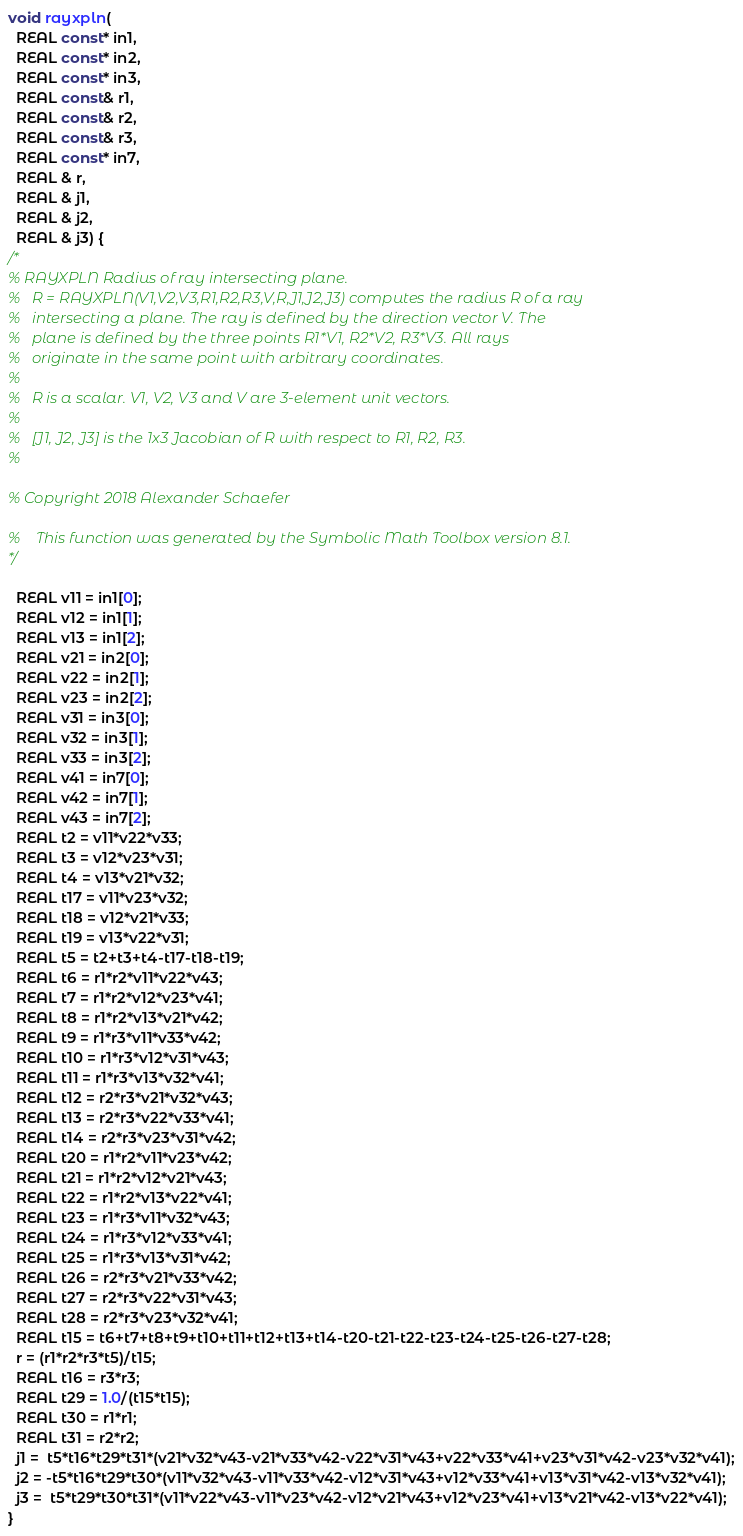<code> <loc_0><loc_0><loc_500><loc_500><_C_>void rayxpln(
  REAL const* in1,
  REAL const* in2,
  REAL const* in3,
  REAL const& r1,
  REAL const& r2,
  REAL const& r3,
  REAL const* in7,
  REAL & r,
  REAL & j1,
  REAL & j2,
  REAL & j3) {
/*
% RAYXPLN Radius of ray intersecting plane.
%   R = RAYXPLN(V1,V2,V3,R1,R2,R3,V,R,J1,J2,J3) computes the radius R of a ray
%   intersecting a plane. The ray is defined by the direction vector V. The
%   plane is defined by the three points R1*V1, R2*V2, R3*V3. All rays
%   originate in the same point with arbitrary coordinates.
%
%   R is a scalar. V1, V2, V3 and V are 3-element unit vectors.
%
%   [J1, J2, J3] is the 1x3 Jacobian of R with respect to R1, R2, R3.
%
  
% Copyright 2018 Alexander Schaefer

%    This function was generated by the Symbolic Math Toolbox version 8.1.
*/

  REAL v11 = in1[0];
  REAL v12 = in1[1];
  REAL v13 = in1[2];
  REAL v21 = in2[0];
  REAL v22 = in2[1];
  REAL v23 = in2[2];
  REAL v31 = in3[0];
  REAL v32 = in3[1];
  REAL v33 = in3[2];
  REAL v41 = in7[0];
  REAL v42 = in7[1];
  REAL v43 = in7[2];
  REAL t2 = v11*v22*v33;
  REAL t3 = v12*v23*v31;
  REAL t4 = v13*v21*v32;
  REAL t17 = v11*v23*v32;
  REAL t18 = v12*v21*v33;
  REAL t19 = v13*v22*v31;
  REAL t5 = t2+t3+t4-t17-t18-t19;
  REAL t6 = r1*r2*v11*v22*v43;
  REAL t7 = r1*r2*v12*v23*v41;
  REAL t8 = r1*r2*v13*v21*v42;
  REAL t9 = r1*r3*v11*v33*v42;
  REAL t10 = r1*r3*v12*v31*v43;
  REAL t11 = r1*r3*v13*v32*v41;
  REAL t12 = r2*r3*v21*v32*v43;
  REAL t13 = r2*r3*v22*v33*v41;
  REAL t14 = r2*r3*v23*v31*v42;
  REAL t20 = r1*r2*v11*v23*v42;
  REAL t21 = r1*r2*v12*v21*v43;
  REAL t22 = r1*r2*v13*v22*v41;
  REAL t23 = r1*r3*v11*v32*v43;
  REAL t24 = r1*r3*v12*v33*v41;
  REAL t25 = r1*r3*v13*v31*v42;
  REAL t26 = r2*r3*v21*v33*v42;
  REAL t27 = r2*r3*v22*v31*v43;
  REAL t28 = r2*r3*v23*v32*v41;
  REAL t15 = t6+t7+t8+t9+t10+t11+t12+t13+t14-t20-t21-t22-t23-t24-t25-t26-t27-t28;
  r = (r1*r2*r3*t5)/t15;
  REAL t16 = r3*r3;
  REAL t29 = 1.0/(t15*t15);
  REAL t30 = r1*r1;
  REAL t31 = r2*r2;
  j1 =  t5*t16*t29*t31*(v21*v32*v43-v21*v33*v42-v22*v31*v43+v22*v33*v41+v23*v31*v42-v23*v32*v41);
  j2 = -t5*t16*t29*t30*(v11*v32*v43-v11*v33*v42-v12*v31*v43+v12*v33*v41+v13*v31*v42-v13*v32*v41);
  j3 =  t5*t29*t30*t31*(v11*v22*v43-v11*v23*v42-v12*v21*v43+v12*v23*v41+v13*v21*v42-v13*v22*v41);
}
</code> 